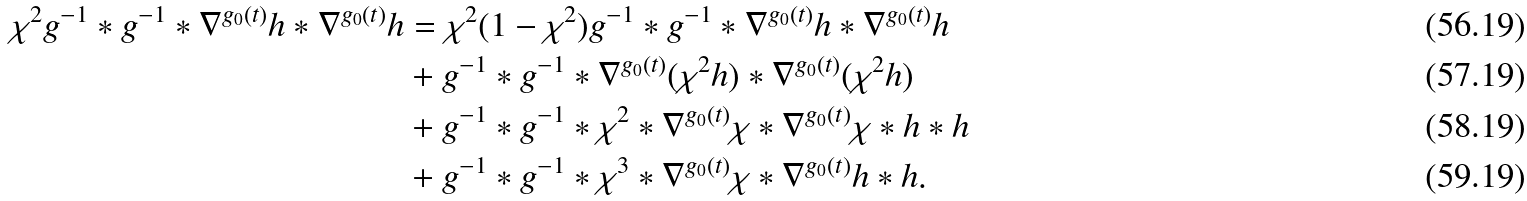Convert formula to latex. <formula><loc_0><loc_0><loc_500><loc_500>\chi ^ { 2 } g ^ { - 1 } * g ^ { - 1 } * \nabla ^ { g _ { 0 } ( t ) } h * \nabla ^ { g _ { 0 } ( t ) } h & = \chi ^ { 2 } ( 1 - \chi ^ { 2 } ) g ^ { - 1 } * g ^ { - 1 } * \nabla ^ { g _ { 0 } ( t ) } h * \nabla ^ { g _ { 0 } ( t ) } h \\ & + g ^ { - 1 } * g ^ { - 1 } * \nabla ^ { g _ { 0 } ( t ) } ( \chi ^ { 2 } h ) * \nabla ^ { g _ { 0 } ( t ) } ( \chi ^ { 2 } h ) \\ & + g ^ { - 1 } * g ^ { - 1 } * \chi ^ { 2 } * \nabla ^ { g _ { 0 } ( t ) } \chi * \nabla ^ { g _ { 0 } ( t ) } \chi * h * h \\ & + g ^ { - 1 } * g ^ { - 1 } * \chi ^ { 3 } * \nabla ^ { g _ { 0 } ( t ) } \chi * \nabla ^ { g _ { 0 } ( t ) } h * h .</formula> 